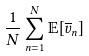Convert formula to latex. <formula><loc_0><loc_0><loc_500><loc_500>\frac { 1 } { N } \sum _ { n = 1 } ^ { N } \mathbb { E } [ \overline { v } _ { n } ]</formula> 